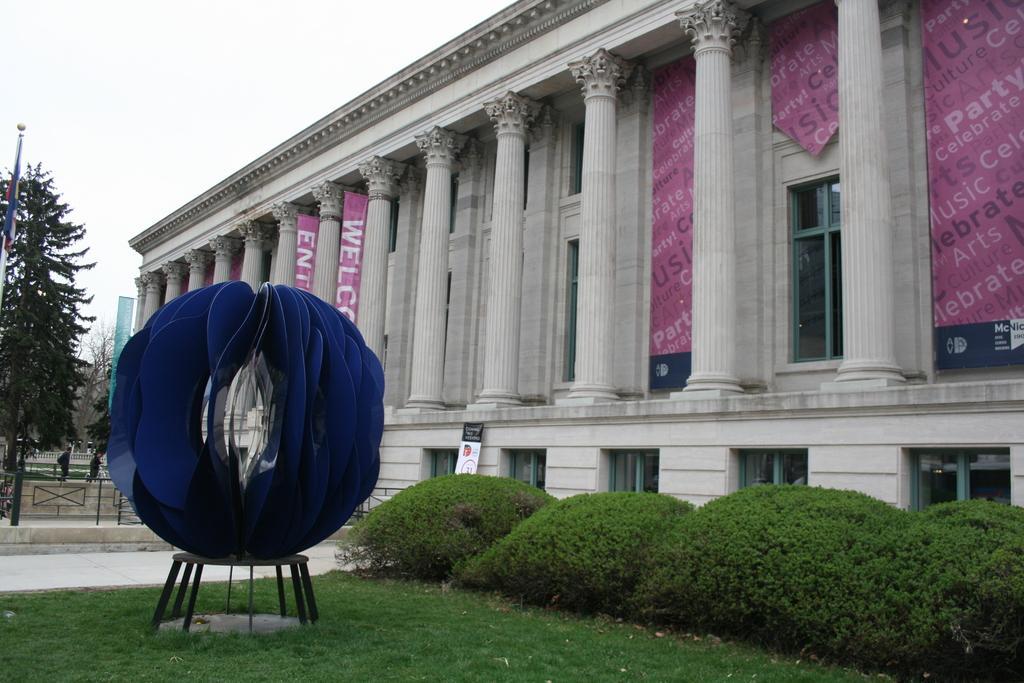How would you summarize this image in a sentence or two? This picture is clicked outside. On the left there is a blue color object placed on the top of the table and we can see the green grass, plants and a flag and the trees. On the right there is a building and we can see the pillars and windows of the building and we can see the banners on which we can see the text. In the background we can see the sky, group of persons, metal rods and some other objects. 